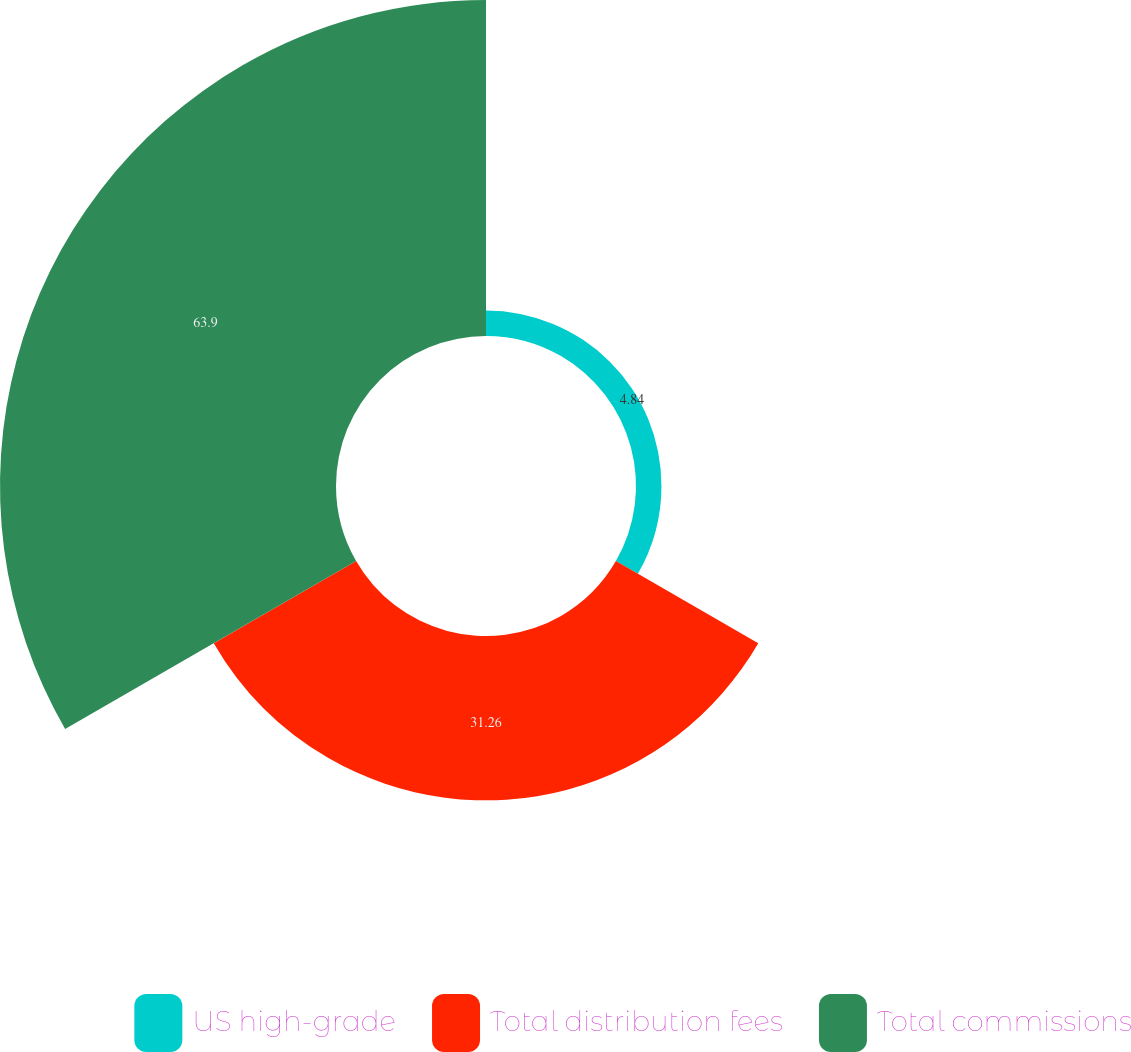Convert chart to OTSL. <chart><loc_0><loc_0><loc_500><loc_500><pie_chart><fcel>US high-grade<fcel>Total distribution fees<fcel>Total commissions<nl><fcel>4.84%<fcel>31.26%<fcel>63.9%<nl></chart> 